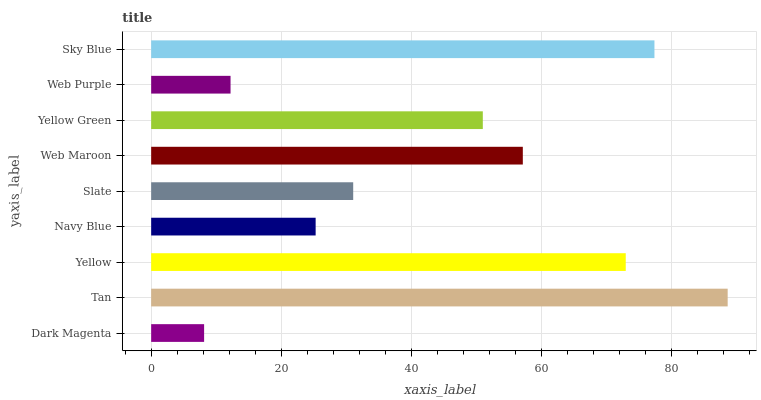Is Dark Magenta the minimum?
Answer yes or no. Yes. Is Tan the maximum?
Answer yes or no. Yes. Is Yellow the minimum?
Answer yes or no. No. Is Yellow the maximum?
Answer yes or no. No. Is Tan greater than Yellow?
Answer yes or no. Yes. Is Yellow less than Tan?
Answer yes or no. Yes. Is Yellow greater than Tan?
Answer yes or no. No. Is Tan less than Yellow?
Answer yes or no. No. Is Yellow Green the high median?
Answer yes or no. Yes. Is Yellow Green the low median?
Answer yes or no. Yes. Is Web Purple the high median?
Answer yes or no. No. Is Navy Blue the low median?
Answer yes or no. No. 